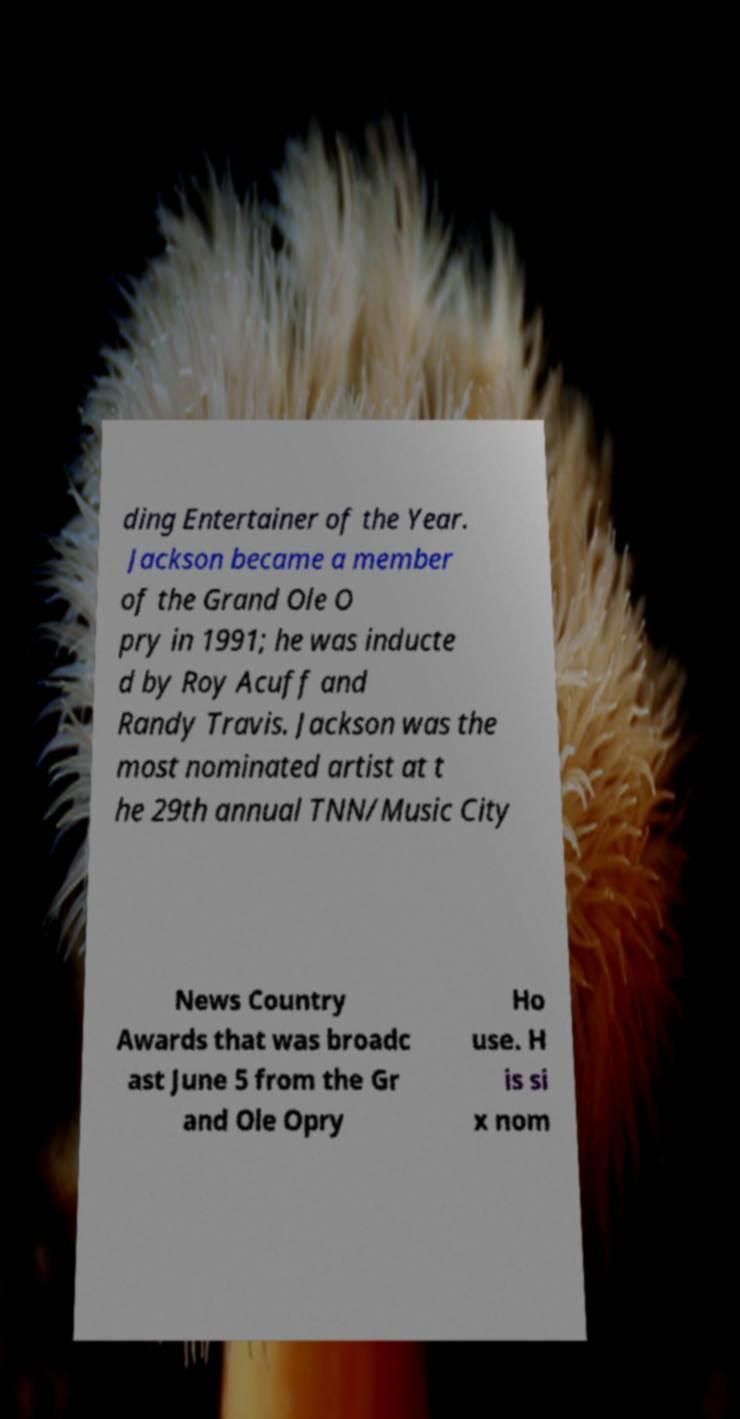What messages or text are displayed in this image? I need them in a readable, typed format. ding Entertainer of the Year. Jackson became a member of the Grand Ole O pry in 1991; he was inducte d by Roy Acuff and Randy Travis. Jackson was the most nominated artist at t he 29th annual TNN/Music City News Country Awards that was broadc ast June 5 from the Gr and Ole Opry Ho use. H is si x nom 